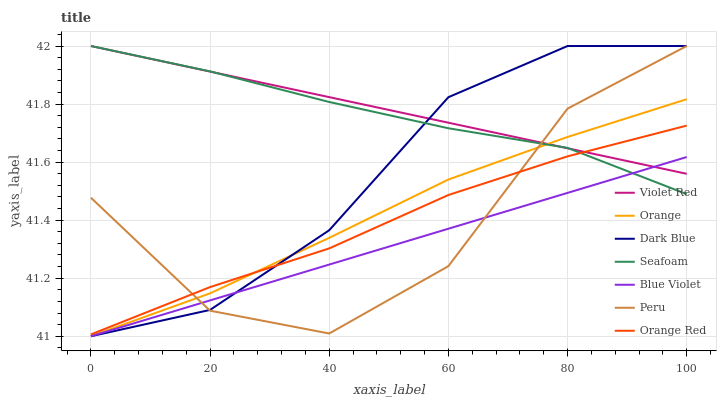Does Seafoam have the minimum area under the curve?
Answer yes or no. No. Does Seafoam have the maximum area under the curve?
Answer yes or no. No. Is Seafoam the smoothest?
Answer yes or no. No. Is Seafoam the roughest?
Answer yes or no. No. Does Seafoam have the lowest value?
Answer yes or no. No. Does Orange have the highest value?
Answer yes or no. No. Is Blue Violet less than Orange Red?
Answer yes or no. Yes. Is Orange Red greater than Blue Violet?
Answer yes or no. Yes. Does Blue Violet intersect Orange Red?
Answer yes or no. No. 